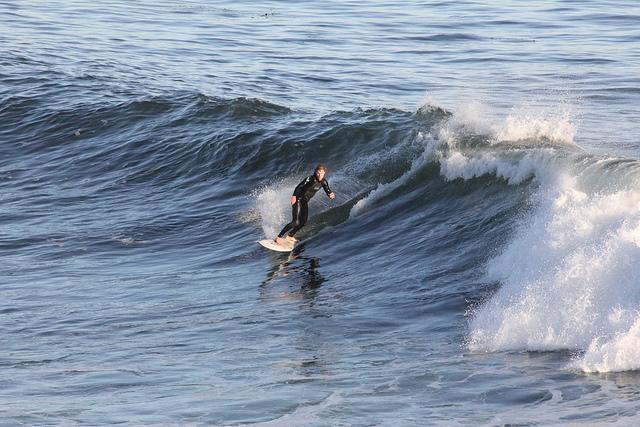How many surfers are on their surfboards?
Give a very brief answer. 1. 